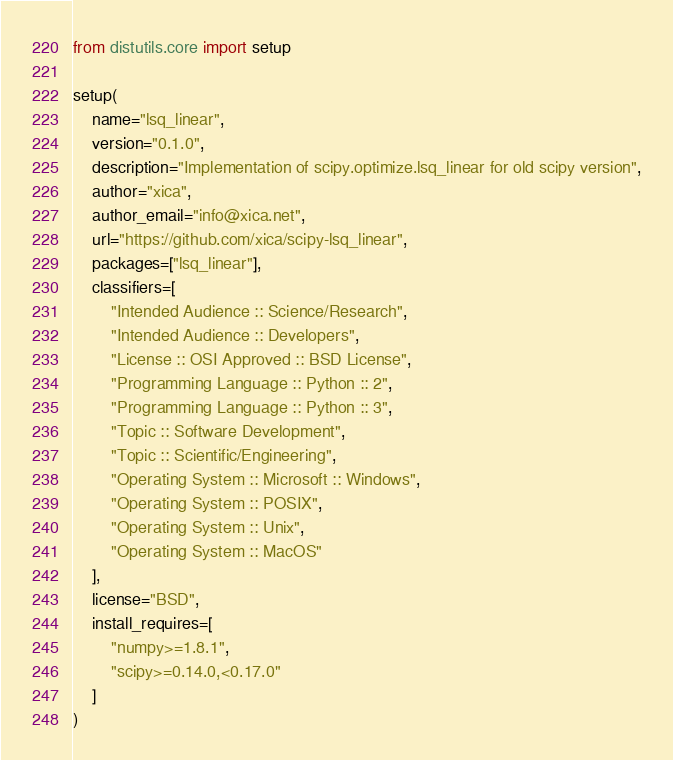<code> <loc_0><loc_0><loc_500><loc_500><_Python_>from distutils.core import setup

setup(
    name="lsq_linear",
    version="0.1.0",
    description="Implementation of scipy.optimize.lsq_linear for old scipy version",
    author="xica",
    author_email="info@xica.net",
    url="https://github.com/xica/scipy-lsq_linear",
    packages=["lsq_linear"],
    classifiers=[
        "Intended Audience :: Science/Research",
        "Intended Audience :: Developers",
        "License :: OSI Approved :: BSD License",
        "Programming Language :: Python :: 2",
        "Programming Language :: Python :: 3",
        "Topic :: Software Development",
        "Topic :: Scientific/Engineering",
        "Operating System :: Microsoft :: Windows",
        "Operating System :: POSIX",
        "Operating System :: Unix",
        "Operating System :: MacOS"
    ],
    license="BSD",
    install_requires=[
        "numpy>=1.8.1",
        "scipy>=0.14.0,<0.17.0"
    ]
)
</code> 